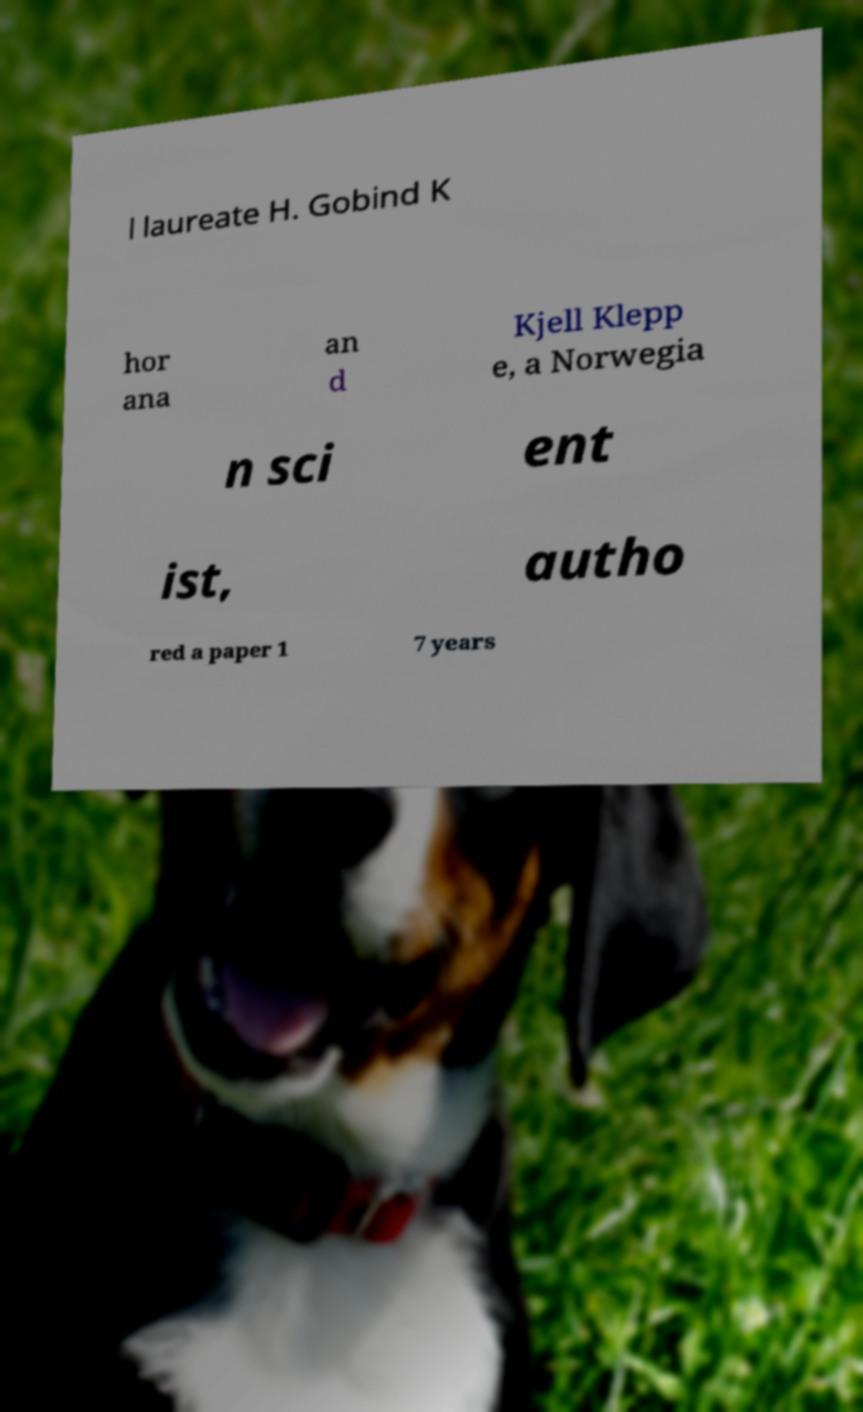I need the written content from this picture converted into text. Can you do that? l laureate H. Gobind K hor ana an d Kjell Klepp e, a Norwegia n sci ent ist, autho red a paper 1 7 years 